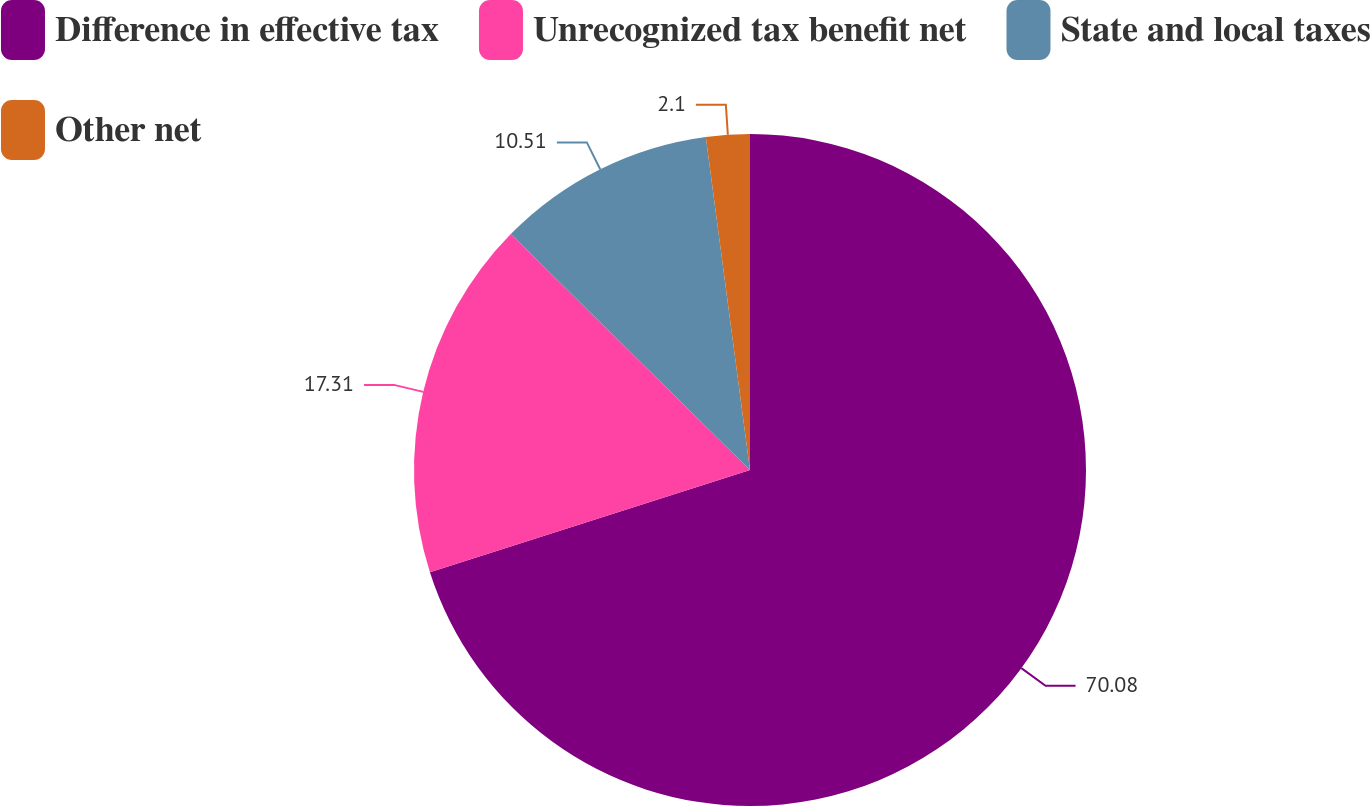<chart> <loc_0><loc_0><loc_500><loc_500><pie_chart><fcel>Difference in effective tax<fcel>Unrecognized tax benefit net<fcel>State and local taxes<fcel>Other net<nl><fcel>70.08%<fcel>17.31%<fcel>10.51%<fcel>2.1%<nl></chart> 